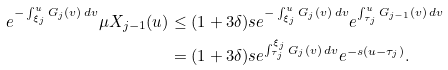<formula> <loc_0><loc_0><loc_500><loc_500>e ^ { - \int _ { \xi _ { j } } ^ { u } G _ { j } ( v ) \, d v } \mu X _ { j - 1 } ( u ) & \leq ( 1 + 3 \delta ) s e ^ { - \int _ { \xi _ { j } } ^ { u } G _ { j } ( v ) \, d v } e ^ { \int _ { \tau _ { j } } ^ { u } G _ { j - 1 } ( v ) \, d v } \\ & = ( 1 + 3 \delta ) s e ^ { \int _ { \tau _ { j } } ^ { \xi _ { j } } G _ { j } ( v ) \, d v } e ^ { - s ( u - \tau _ { j } ) } .</formula> 